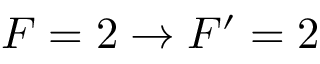<formula> <loc_0><loc_0><loc_500><loc_500>F = 2 \rightarrow F ^ { \prime } = 2</formula> 